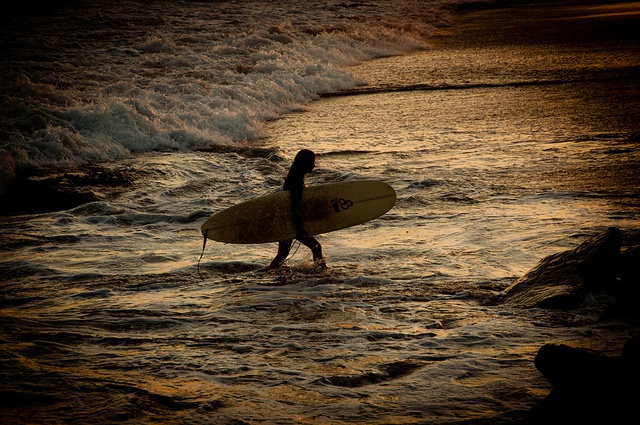Describe the objects in this image and their specific colors. I can see surfboard in black and gray tones and people in black, maroon, and tan tones in this image. 